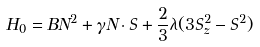Convert formula to latex. <formula><loc_0><loc_0><loc_500><loc_500>H _ { 0 } = B N ^ { 2 } + \gamma N \cdot S + \frac { 2 } { 3 } \lambda ( 3 S _ { z } ^ { 2 } - S ^ { 2 } )</formula> 